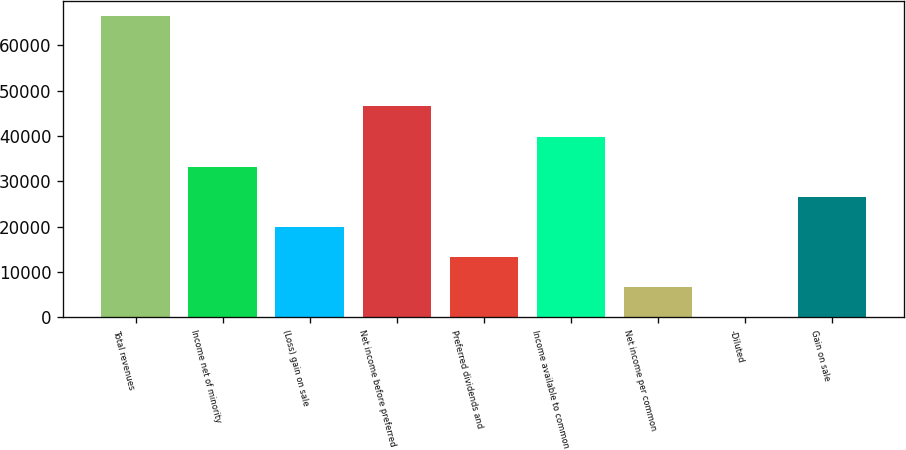<chart> <loc_0><loc_0><loc_500><loc_500><bar_chart><fcel>Total revenues<fcel>Income net of minority<fcel>(Loss) gain on sale<fcel>Net income before preferred<fcel>Preferred dividends and<fcel>Income available to common<fcel>Net income per common<fcel>-Diluted<fcel>Gain on sale<nl><fcel>66476<fcel>33238.3<fcel>19943.2<fcel>46533.4<fcel>13295.7<fcel>39885.8<fcel>6648.14<fcel>0.6<fcel>26590.8<nl></chart> 